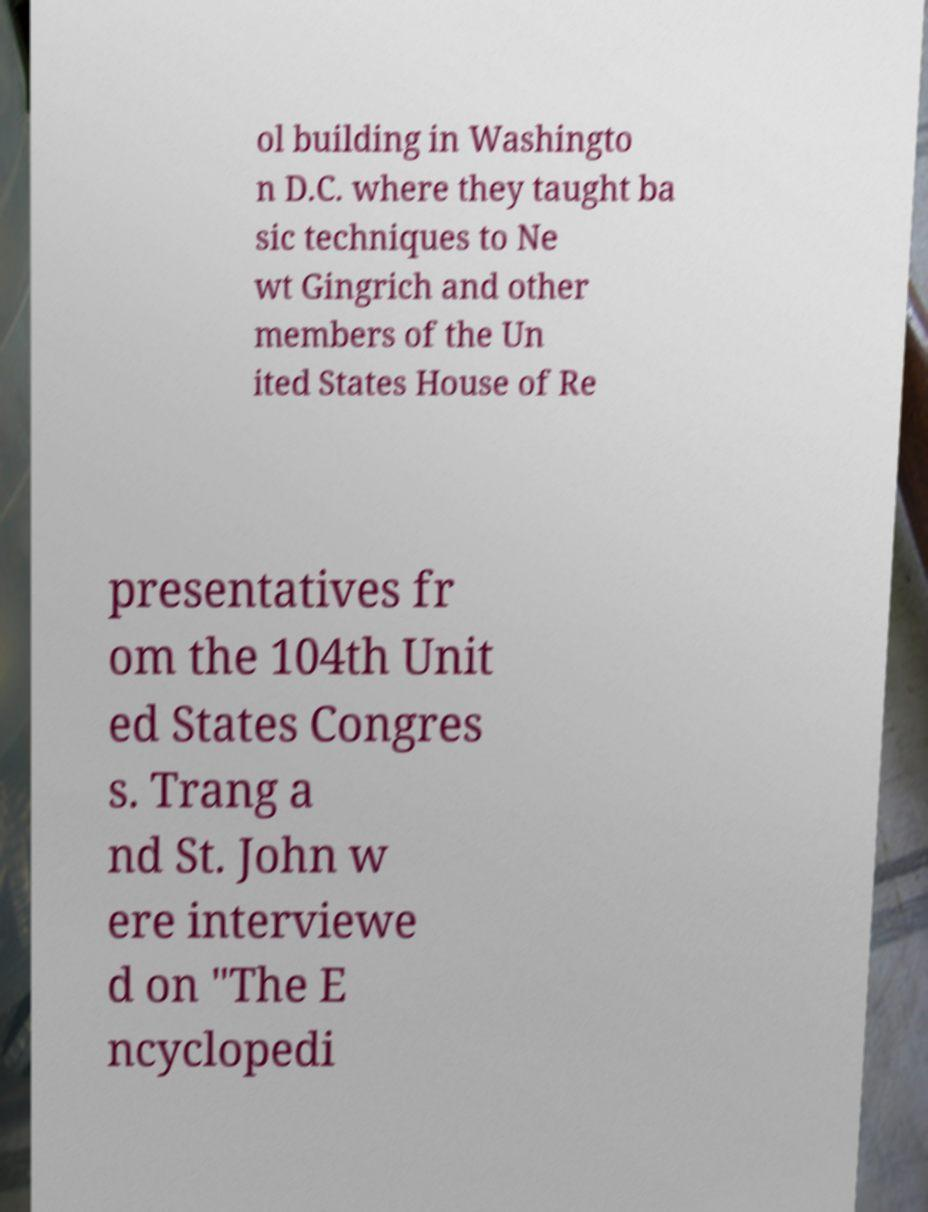Could you extract and type out the text from this image? ol building in Washingto n D.C. where they taught ba sic techniques to Ne wt Gingrich and other members of the Un ited States House of Re presentatives fr om the 104th Unit ed States Congres s. Trang a nd St. John w ere interviewe d on "The E ncyclopedi 